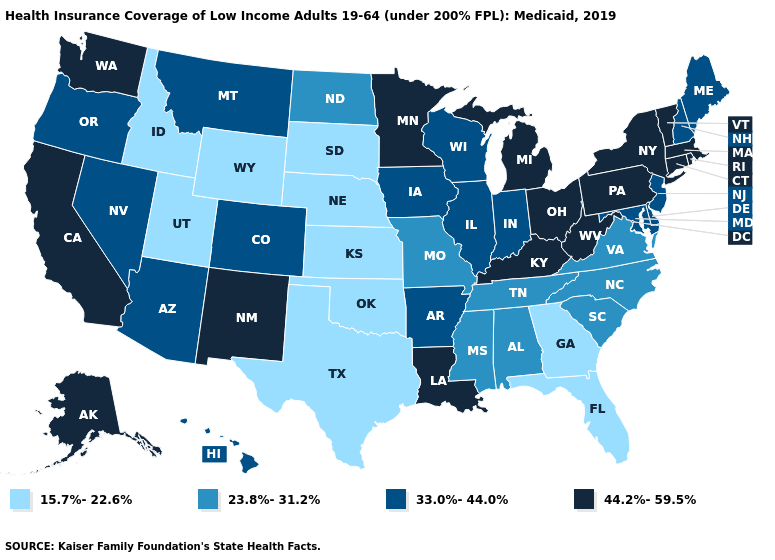Does the first symbol in the legend represent the smallest category?
Short answer required. Yes. Which states have the lowest value in the USA?
Be succinct. Florida, Georgia, Idaho, Kansas, Nebraska, Oklahoma, South Dakota, Texas, Utah, Wyoming. Which states have the highest value in the USA?
Answer briefly. Alaska, California, Connecticut, Kentucky, Louisiana, Massachusetts, Michigan, Minnesota, New Mexico, New York, Ohio, Pennsylvania, Rhode Island, Vermont, Washington, West Virginia. Name the states that have a value in the range 23.8%-31.2%?
Concise answer only. Alabama, Mississippi, Missouri, North Carolina, North Dakota, South Carolina, Tennessee, Virginia. Does Rhode Island have the highest value in the USA?
Be succinct. Yes. Does Colorado have the lowest value in the West?
Give a very brief answer. No. What is the highest value in the Northeast ?
Write a very short answer. 44.2%-59.5%. Name the states that have a value in the range 15.7%-22.6%?
Short answer required. Florida, Georgia, Idaho, Kansas, Nebraska, Oklahoma, South Dakota, Texas, Utah, Wyoming. Does Ohio have a lower value than Nevada?
Answer briefly. No. What is the lowest value in the MidWest?
Be succinct. 15.7%-22.6%. Which states hav the highest value in the South?
Be succinct. Kentucky, Louisiana, West Virginia. What is the lowest value in states that border Georgia?
Short answer required. 15.7%-22.6%. Among the states that border Colorado , does New Mexico have the highest value?
Give a very brief answer. Yes. Does the first symbol in the legend represent the smallest category?
Keep it brief. Yes. What is the value of Rhode Island?
Give a very brief answer. 44.2%-59.5%. 